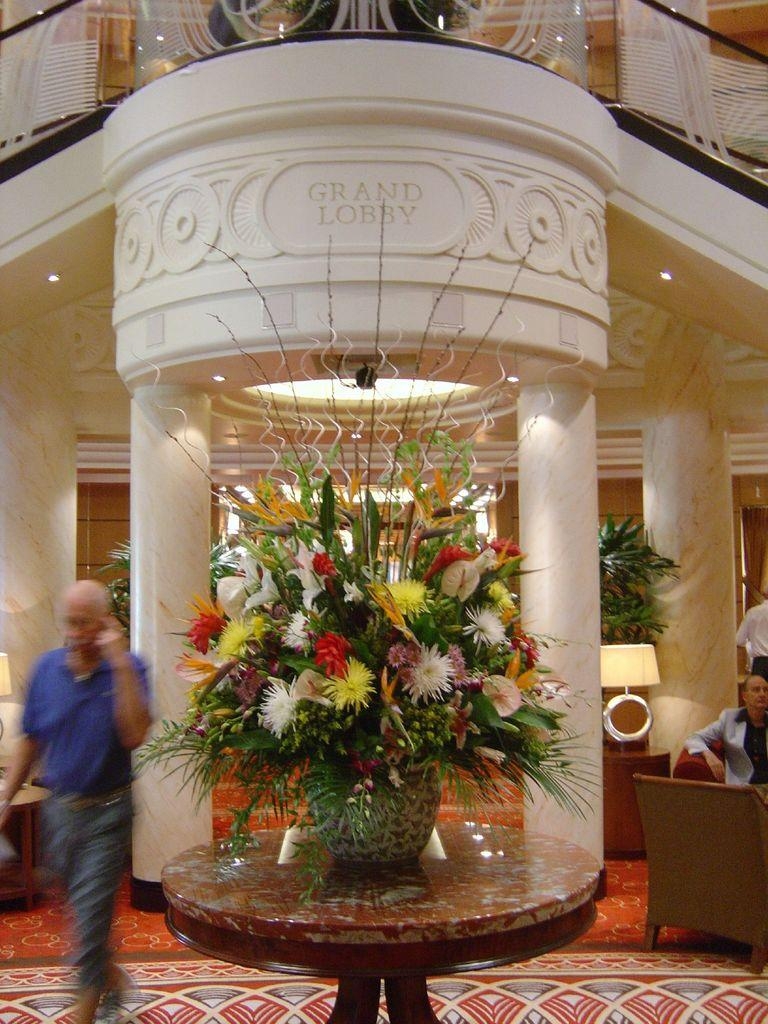What type of location is depicted in the image? The image shows an inside view of a building. What can be seen on the table in the image? There is a flower vase on a table in the image. What type of furniture is present in the image? There is a chair in the image. What type of lighting is present in the image? There are lamps and lights in the image. What type of vegetation is present in the image? House plants are present in the image. Are there any people in the image? Yes, there are people in the image. What type of field can be seen in the image? There is no field present in the image; it shows an inside view of a building. What is the tendency of the bears in the image? There are no bears present in the image. 